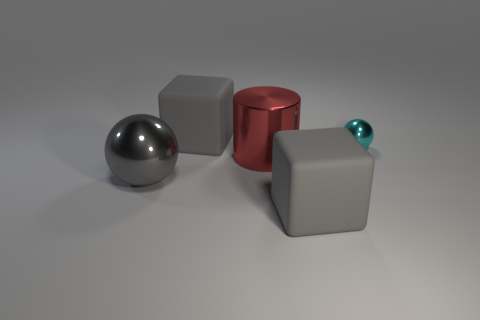What is the material of the small cyan ball?
Make the answer very short. Metal. There is a thing that is behind the small cyan sphere; what is it made of?
Offer a terse response. Rubber. Are there any other things that have the same color as the big shiny ball?
Provide a succinct answer. Yes. What is the size of the cyan thing that is made of the same material as the red cylinder?
Provide a succinct answer. Small. How many small things are either gray matte things or gray metallic objects?
Make the answer very short. 0. There is a rubber thing in front of the cyan metal thing that is on the right side of the large gray matte thing to the left of the red cylinder; what size is it?
Your answer should be very brief. Large. What number of red objects are the same size as the cyan object?
Ensure brevity in your answer.  0. What number of things are small red matte objects or large metallic objects behind the large gray metallic object?
Your answer should be compact. 1. What shape is the red metallic object?
Your answer should be compact. Cylinder. The ball that is the same size as the cylinder is what color?
Provide a short and direct response. Gray. 